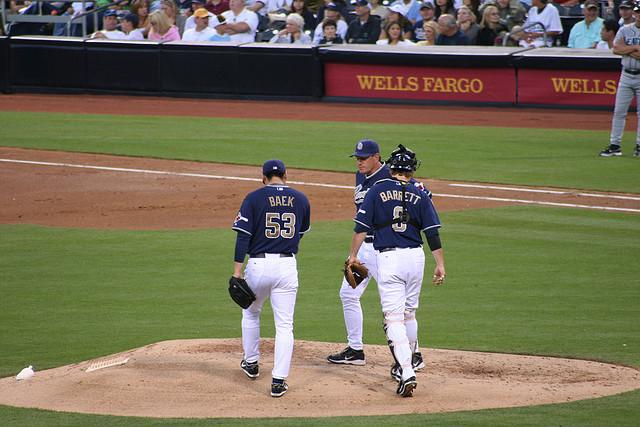What are the walls used for?
Answer briefly. Protection. What is the they wearing on their hands?
Write a very short answer. Gloves. What number is on the blue uniform?
Short answer required. 53. What name is above the number 53?
Write a very short answer. Baek. 